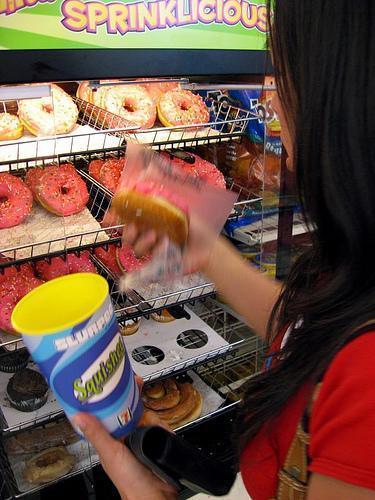How many donuts can you see?
Give a very brief answer. 3. How many kites are in this picture?
Give a very brief answer. 0. 